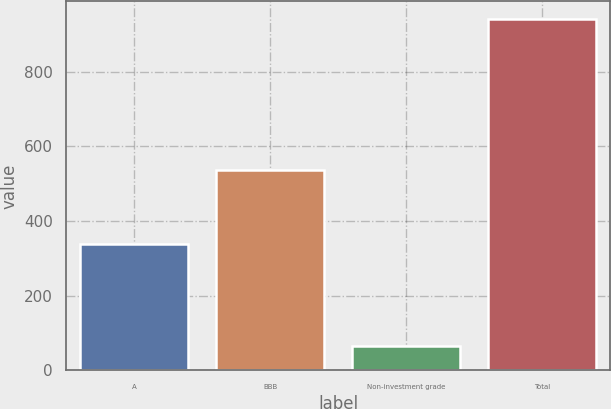Convert chart. <chart><loc_0><loc_0><loc_500><loc_500><bar_chart><fcel>A<fcel>BBB<fcel>Non-investment grade<fcel>Total<nl><fcel>338<fcel>537<fcel>66<fcel>941<nl></chart> 